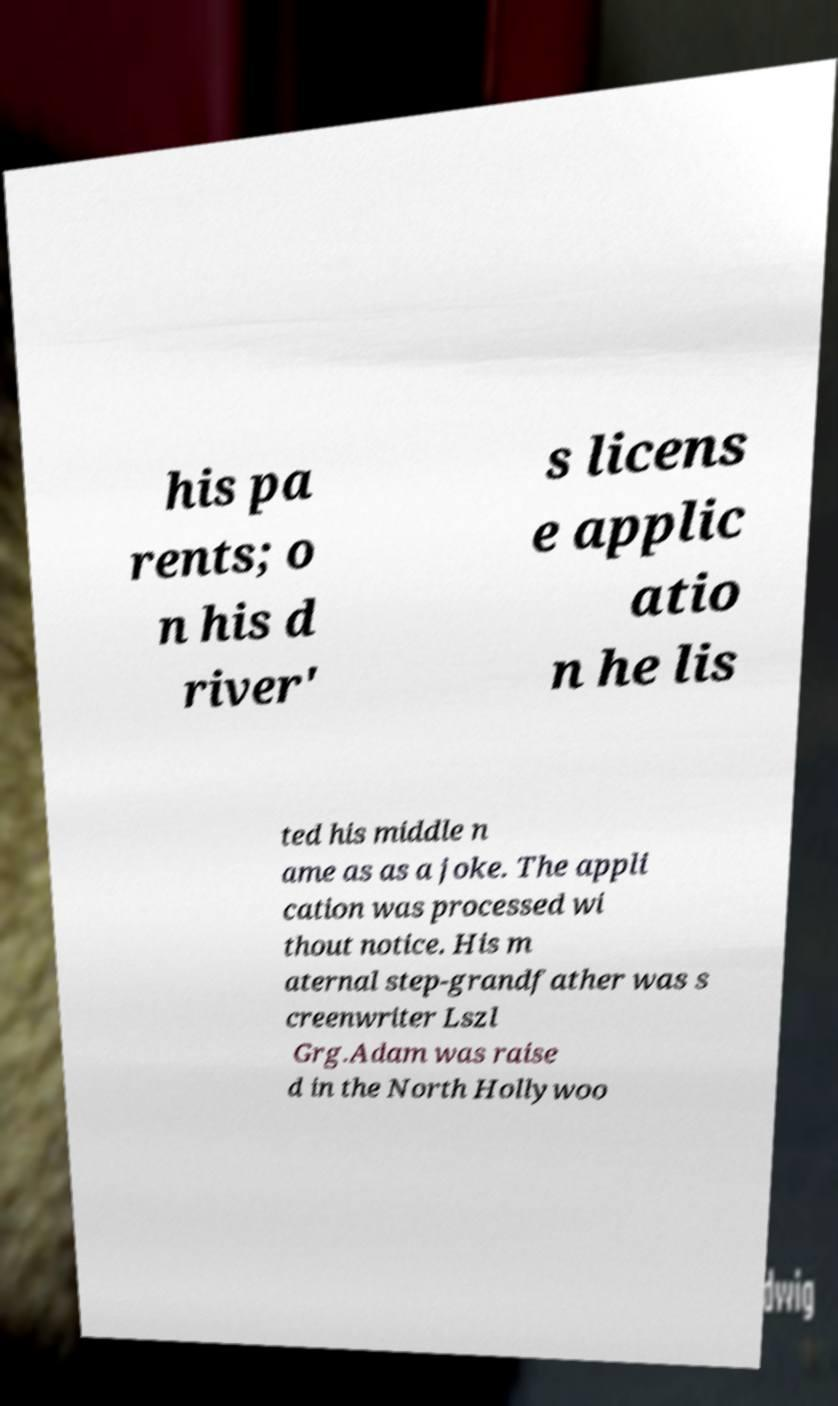Could you extract and type out the text from this image? his pa rents; o n his d river' s licens e applic atio n he lis ted his middle n ame as as a joke. The appli cation was processed wi thout notice. His m aternal step-grandfather was s creenwriter Lszl Grg.Adam was raise d in the North Hollywoo 